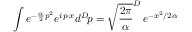<formula> <loc_0><loc_0><loc_500><loc_500>\int e ^ { - { \frac { \alpha } { 2 } } p ^ { 2 } } e ^ { i p \cdot x } d ^ { D } \, p = \sqrt { \frac { 2 \pi } { \alpha } } ^ { D } \, e ^ { - x ^ { 2 } / 2 \alpha }</formula> 